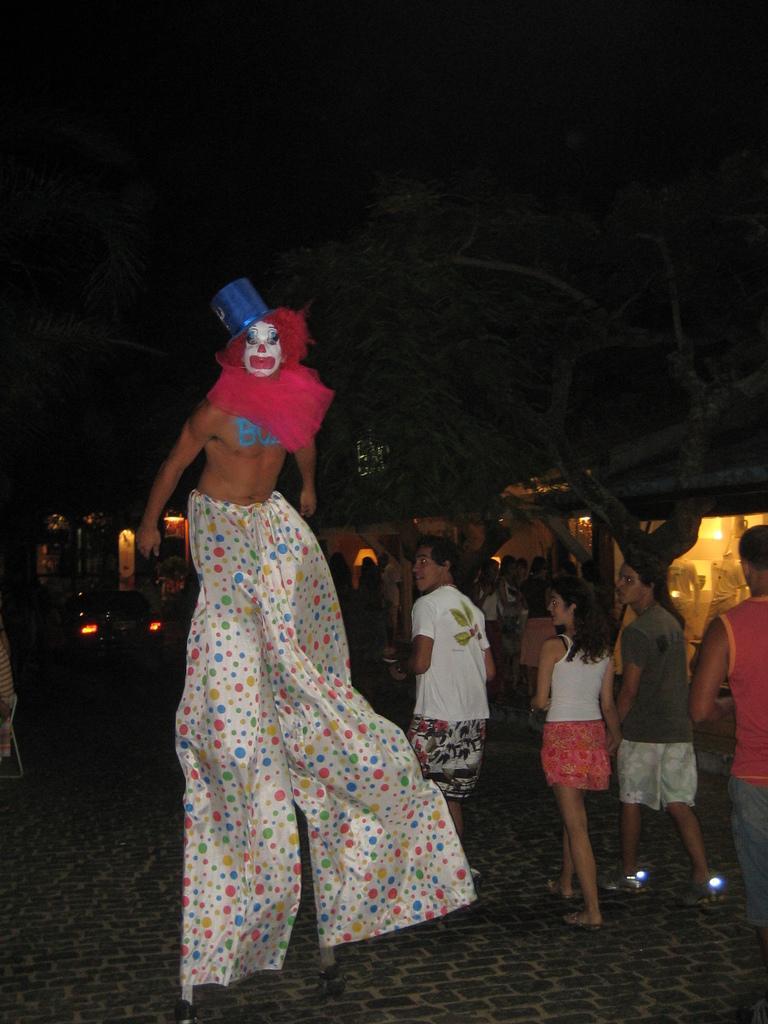Can you describe this image briefly? In this image we can see the house with lights and there is the vehicle parked in front of the house. And there are people walking on the ground and we can see the person in a costume. 